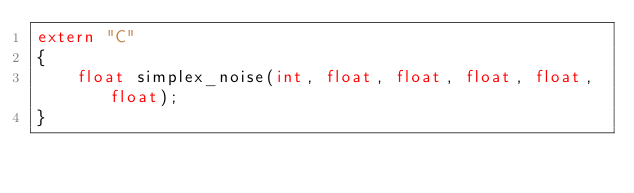<code> <loc_0><loc_0><loc_500><loc_500><_C++_>extern "C"
{
	float simplex_noise(int, float, float, float, float, float);
}</code> 